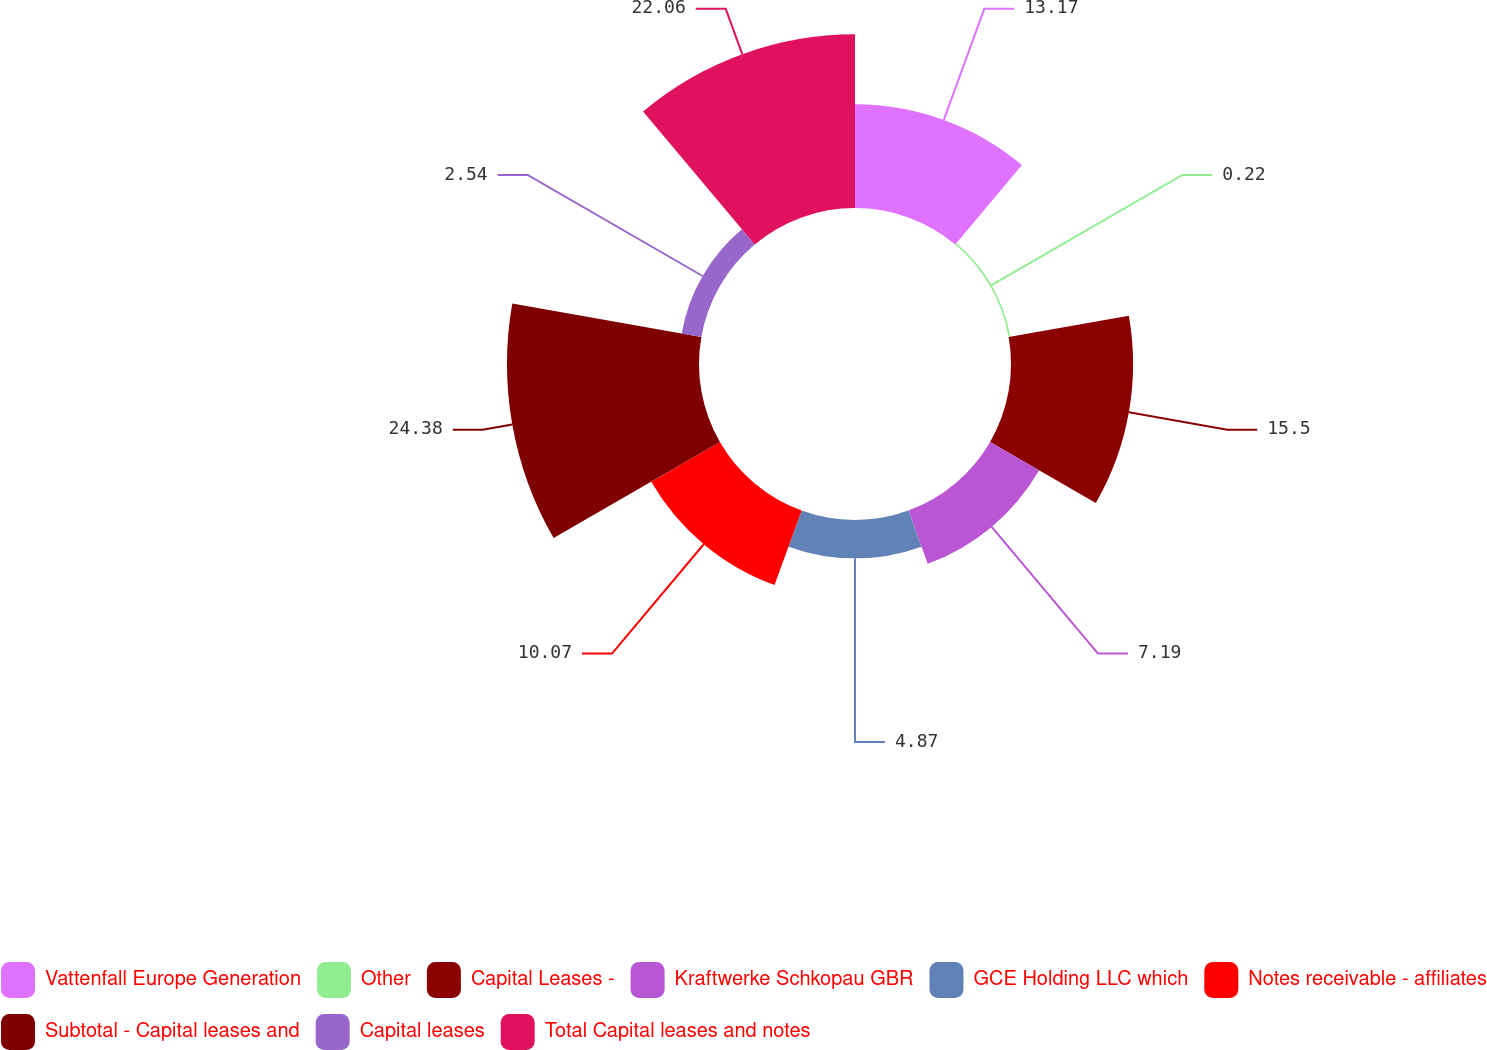<chart> <loc_0><loc_0><loc_500><loc_500><pie_chart><fcel>Vattenfall Europe Generation<fcel>Other<fcel>Capital Leases -<fcel>Kraftwerke Schkopau GBR<fcel>GCE Holding LLC which<fcel>Notes receivable - affiliates<fcel>Subtotal - Capital leases and<fcel>Capital leases<fcel>Total Capital leases and notes<nl><fcel>13.17%<fcel>0.22%<fcel>15.5%<fcel>7.19%<fcel>4.87%<fcel>10.07%<fcel>24.38%<fcel>2.54%<fcel>22.06%<nl></chart> 